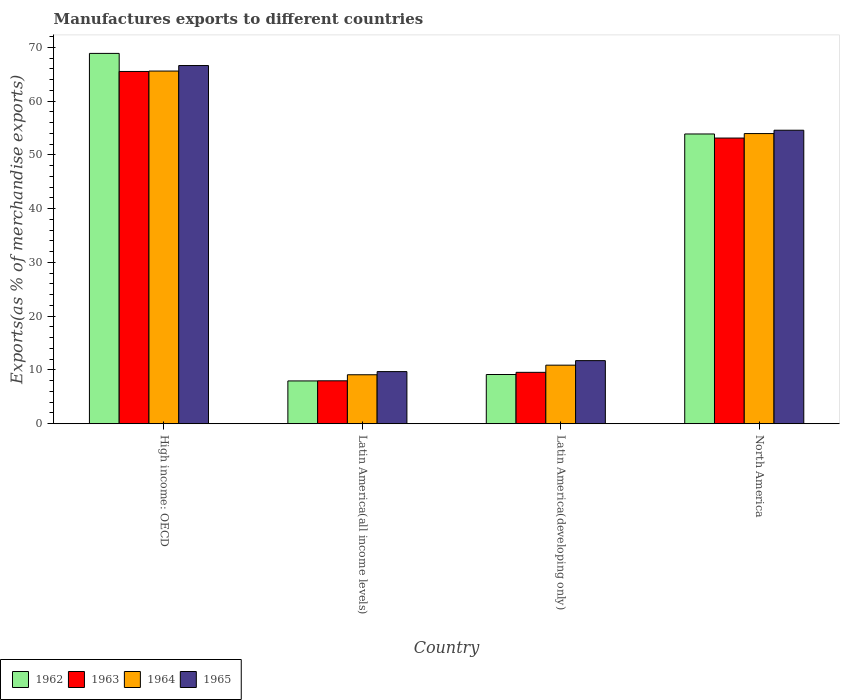Are the number of bars on each tick of the X-axis equal?
Ensure brevity in your answer.  Yes. In how many cases, is the number of bars for a given country not equal to the number of legend labels?
Provide a succinct answer. 0. What is the percentage of exports to different countries in 1962 in High income: OECD?
Give a very brief answer. 68.9. Across all countries, what is the maximum percentage of exports to different countries in 1963?
Keep it short and to the point. 65.54. Across all countries, what is the minimum percentage of exports to different countries in 1964?
Offer a terse response. 9.11. In which country was the percentage of exports to different countries in 1965 maximum?
Your response must be concise. High income: OECD. In which country was the percentage of exports to different countries in 1962 minimum?
Your answer should be very brief. Latin America(all income levels). What is the total percentage of exports to different countries in 1962 in the graph?
Your response must be concise. 139.93. What is the difference between the percentage of exports to different countries in 1965 in High income: OECD and that in Latin America(all income levels)?
Your answer should be compact. 56.94. What is the difference between the percentage of exports to different countries in 1962 in Latin America(all income levels) and the percentage of exports to different countries in 1965 in Latin America(developing only)?
Ensure brevity in your answer.  -3.78. What is the average percentage of exports to different countries in 1963 per country?
Offer a terse response. 34.06. What is the difference between the percentage of exports to different countries of/in 1963 and percentage of exports to different countries of/in 1964 in Latin America(developing only)?
Your answer should be very brief. -1.33. What is the ratio of the percentage of exports to different countries in 1964 in Latin America(all income levels) to that in Latin America(developing only)?
Your answer should be compact. 0.84. Is the percentage of exports to different countries in 1962 in Latin America(all income levels) less than that in Latin America(developing only)?
Give a very brief answer. Yes. What is the difference between the highest and the second highest percentage of exports to different countries in 1962?
Your response must be concise. -59.74. What is the difference between the highest and the lowest percentage of exports to different countries in 1964?
Offer a very short reply. 56.5. In how many countries, is the percentage of exports to different countries in 1962 greater than the average percentage of exports to different countries in 1962 taken over all countries?
Offer a terse response. 2. Is the sum of the percentage of exports to different countries in 1964 in High income: OECD and Latin America(all income levels) greater than the maximum percentage of exports to different countries in 1963 across all countries?
Provide a short and direct response. Yes. What does the 3rd bar from the left in High income: OECD represents?
Keep it short and to the point. 1964. What is the difference between two consecutive major ticks on the Y-axis?
Ensure brevity in your answer.  10. Are the values on the major ticks of Y-axis written in scientific E-notation?
Provide a succinct answer. No. How many legend labels are there?
Make the answer very short. 4. How are the legend labels stacked?
Keep it short and to the point. Horizontal. What is the title of the graph?
Make the answer very short. Manufactures exports to different countries. Does "1968" appear as one of the legend labels in the graph?
Keep it short and to the point. No. What is the label or title of the X-axis?
Your response must be concise. Country. What is the label or title of the Y-axis?
Your answer should be very brief. Exports(as % of merchandise exports). What is the Exports(as % of merchandise exports) in 1962 in High income: OECD?
Provide a succinct answer. 68.9. What is the Exports(as % of merchandise exports) of 1963 in High income: OECD?
Give a very brief answer. 65.54. What is the Exports(as % of merchandise exports) of 1964 in High income: OECD?
Provide a short and direct response. 65.61. What is the Exports(as % of merchandise exports) of 1965 in High income: OECD?
Ensure brevity in your answer.  66.64. What is the Exports(as % of merchandise exports) in 1962 in Latin America(all income levels)?
Keep it short and to the point. 7.96. What is the Exports(as % of merchandise exports) of 1963 in Latin America(all income levels)?
Your answer should be very brief. 7.99. What is the Exports(as % of merchandise exports) of 1964 in Latin America(all income levels)?
Your answer should be very brief. 9.11. What is the Exports(as % of merchandise exports) in 1965 in Latin America(all income levels)?
Provide a succinct answer. 9.7. What is the Exports(as % of merchandise exports) in 1962 in Latin America(developing only)?
Your answer should be very brief. 9.16. What is the Exports(as % of merchandise exports) in 1963 in Latin America(developing only)?
Your answer should be compact. 9.56. What is the Exports(as % of merchandise exports) in 1964 in Latin America(developing only)?
Offer a very short reply. 10.9. What is the Exports(as % of merchandise exports) in 1965 in Latin America(developing only)?
Provide a short and direct response. 11.74. What is the Exports(as % of merchandise exports) in 1962 in North America?
Your answer should be compact. 53.91. What is the Exports(as % of merchandise exports) in 1963 in North America?
Your answer should be compact. 53.15. What is the Exports(as % of merchandise exports) of 1964 in North America?
Offer a terse response. 53.98. What is the Exports(as % of merchandise exports) of 1965 in North America?
Your answer should be compact. 54.61. Across all countries, what is the maximum Exports(as % of merchandise exports) of 1962?
Ensure brevity in your answer.  68.9. Across all countries, what is the maximum Exports(as % of merchandise exports) in 1963?
Offer a very short reply. 65.54. Across all countries, what is the maximum Exports(as % of merchandise exports) in 1964?
Your answer should be compact. 65.61. Across all countries, what is the maximum Exports(as % of merchandise exports) in 1965?
Ensure brevity in your answer.  66.64. Across all countries, what is the minimum Exports(as % of merchandise exports) of 1962?
Offer a terse response. 7.96. Across all countries, what is the minimum Exports(as % of merchandise exports) in 1963?
Offer a very short reply. 7.99. Across all countries, what is the minimum Exports(as % of merchandise exports) of 1964?
Ensure brevity in your answer.  9.11. Across all countries, what is the minimum Exports(as % of merchandise exports) of 1965?
Keep it short and to the point. 9.7. What is the total Exports(as % of merchandise exports) of 1962 in the graph?
Make the answer very short. 139.93. What is the total Exports(as % of merchandise exports) of 1963 in the graph?
Ensure brevity in your answer.  136.24. What is the total Exports(as % of merchandise exports) in 1964 in the graph?
Your answer should be compact. 139.6. What is the total Exports(as % of merchandise exports) of 1965 in the graph?
Make the answer very short. 142.68. What is the difference between the Exports(as % of merchandise exports) in 1962 in High income: OECD and that in Latin America(all income levels)?
Provide a short and direct response. 60.93. What is the difference between the Exports(as % of merchandise exports) in 1963 in High income: OECD and that in Latin America(all income levels)?
Keep it short and to the point. 57.55. What is the difference between the Exports(as % of merchandise exports) in 1964 in High income: OECD and that in Latin America(all income levels)?
Make the answer very short. 56.5. What is the difference between the Exports(as % of merchandise exports) of 1965 in High income: OECD and that in Latin America(all income levels)?
Give a very brief answer. 56.94. What is the difference between the Exports(as % of merchandise exports) of 1962 in High income: OECD and that in Latin America(developing only)?
Provide a succinct answer. 59.74. What is the difference between the Exports(as % of merchandise exports) of 1963 in High income: OECD and that in Latin America(developing only)?
Offer a terse response. 55.98. What is the difference between the Exports(as % of merchandise exports) in 1964 in High income: OECD and that in Latin America(developing only)?
Provide a succinct answer. 54.72. What is the difference between the Exports(as % of merchandise exports) in 1965 in High income: OECD and that in Latin America(developing only)?
Make the answer very short. 54.9. What is the difference between the Exports(as % of merchandise exports) in 1962 in High income: OECD and that in North America?
Offer a terse response. 14.99. What is the difference between the Exports(as % of merchandise exports) of 1963 in High income: OECD and that in North America?
Ensure brevity in your answer.  12.39. What is the difference between the Exports(as % of merchandise exports) of 1964 in High income: OECD and that in North America?
Ensure brevity in your answer.  11.63. What is the difference between the Exports(as % of merchandise exports) of 1965 in High income: OECD and that in North America?
Ensure brevity in your answer.  12.03. What is the difference between the Exports(as % of merchandise exports) in 1962 in Latin America(all income levels) and that in Latin America(developing only)?
Ensure brevity in your answer.  -1.2. What is the difference between the Exports(as % of merchandise exports) in 1963 in Latin America(all income levels) and that in Latin America(developing only)?
Your answer should be compact. -1.57. What is the difference between the Exports(as % of merchandise exports) of 1964 in Latin America(all income levels) and that in Latin America(developing only)?
Make the answer very short. -1.78. What is the difference between the Exports(as % of merchandise exports) of 1965 in Latin America(all income levels) and that in Latin America(developing only)?
Ensure brevity in your answer.  -2.04. What is the difference between the Exports(as % of merchandise exports) in 1962 in Latin America(all income levels) and that in North America?
Your answer should be compact. -45.94. What is the difference between the Exports(as % of merchandise exports) in 1963 in Latin America(all income levels) and that in North America?
Your response must be concise. -45.16. What is the difference between the Exports(as % of merchandise exports) of 1964 in Latin America(all income levels) and that in North America?
Make the answer very short. -44.87. What is the difference between the Exports(as % of merchandise exports) of 1965 in Latin America(all income levels) and that in North America?
Provide a succinct answer. -44.91. What is the difference between the Exports(as % of merchandise exports) in 1962 in Latin America(developing only) and that in North America?
Your response must be concise. -44.75. What is the difference between the Exports(as % of merchandise exports) in 1963 in Latin America(developing only) and that in North America?
Keep it short and to the point. -43.59. What is the difference between the Exports(as % of merchandise exports) in 1964 in Latin America(developing only) and that in North America?
Provide a short and direct response. -43.09. What is the difference between the Exports(as % of merchandise exports) in 1965 in Latin America(developing only) and that in North America?
Your response must be concise. -42.87. What is the difference between the Exports(as % of merchandise exports) of 1962 in High income: OECD and the Exports(as % of merchandise exports) of 1963 in Latin America(all income levels)?
Offer a terse response. 60.91. What is the difference between the Exports(as % of merchandise exports) of 1962 in High income: OECD and the Exports(as % of merchandise exports) of 1964 in Latin America(all income levels)?
Make the answer very short. 59.79. What is the difference between the Exports(as % of merchandise exports) of 1962 in High income: OECD and the Exports(as % of merchandise exports) of 1965 in Latin America(all income levels)?
Provide a succinct answer. 59.2. What is the difference between the Exports(as % of merchandise exports) in 1963 in High income: OECD and the Exports(as % of merchandise exports) in 1964 in Latin America(all income levels)?
Keep it short and to the point. 56.43. What is the difference between the Exports(as % of merchandise exports) in 1963 in High income: OECD and the Exports(as % of merchandise exports) in 1965 in Latin America(all income levels)?
Provide a succinct answer. 55.84. What is the difference between the Exports(as % of merchandise exports) of 1964 in High income: OECD and the Exports(as % of merchandise exports) of 1965 in Latin America(all income levels)?
Your answer should be compact. 55.91. What is the difference between the Exports(as % of merchandise exports) in 1962 in High income: OECD and the Exports(as % of merchandise exports) in 1963 in Latin America(developing only)?
Provide a short and direct response. 59.34. What is the difference between the Exports(as % of merchandise exports) in 1962 in High income: OECD and the Exports(as % of merchandise exports) in 1964 in Latin America(developing only)?
Provide a succinct answer. 58. What is the difference between the Exports(as % of merchandise exports) of 1962 in High income: OECD and the Exports(as % of merchandise exports) of 1965 in Latin America(developing only)?
Give a very brief answer. 57.16. What is the difference between the Exports(as % of merchandise exports) in 1963 in High income: OECD and the Exports(as % of merchandise exports) in 1964 in Latin America(developing only)?
Ensure brevity in your answer.  54.64. What is the difference between the Exports(as % of merchandise exports) of 1963 in High income: OECD and the Exports(as % of merchandise exports) of 1965 in Latin America(developing only)?
Offer a terse response. 53.8. What is the difference between the Exports(as % of merchandise exports) in 1964 in High income: OECD and the Exports(as % of merchandise exports) in 1965 in Latin America(developing only)?
Ensure brevity in your answer.  53.87. What is the difference between the Exports(as % of merchandise exports) of 1962 in High income: OECD and the Exports(as % of merchandise exports) of 1963 in North America?
Ensure brevity in your answer.  15.75. What is the difference between the Exports(as % of merchandise exports) of 1962 in High income: OECD and the Exports(as % of merchandise exports) of 1964 in North America?
Ensure brevity in your answer.  14.92. What is the difference between the Exports(as % of merchandise exports) of 1962 in High income: OECD and the Exports(as % of merchandise exports) of 1965 in North America?
Keep it short and to the point. 14.29. What is the difference between the Exports(as % of merchandise exports) in 1963 in High income: OECD and the Exports(as % of merchandise exports) in 1964 in North America?
Ensure brevity in your answer.  11.56. What is the difference between the Exports(as % of merchandise exports) of 1963 in High income: OECD and the Exports(as % of merchandise exports) of 1965 in North America?
Provide a short and direct response. 10.93. What is the difference between the Exports(as % of merchandise exports) of 1964 in High income: OECD and the Exports(as % of merchandise exports) of 1965 in North America?
Provide a short and direct response. 11.01. What is the difference between the Exports(as % of merchandise exports) of 1962 in Latin America(all income levels) and the Exports(as % of merchandise exports) of 1963 in Latin America(developing only)?
Provide a short and direct response. -1.6. What is the difference between the Exports(as % of merchandise exports) in 1962 in Latin America(all income levels) and the Exports(as % of merchandise exports) in 1964 in Latin America(developing only)?
Provide a short and direct response. -2.93. What is the difference between the Exports(as % of merchandise exports) of 1962 in Latin America(all income levels) and the Exports(as % of merchandise exports) of 1965 in Latin America(developing only)?
Make the answer very short. -3.78. What is the difference between the Exports(as % of merchandise exports) in 1963 in Latin America(all income levels) and the Exports(as % of merchandise exports) in 1964 in Latin America(developing only)?
Provide a short and direct response. -2.91. What is the difference between the Exports(as % of merchandise exports) of 1963 in Latin America(all income levels) and the Exports(as % of merchandise exports) of 1965 in Latin America(developing only)?
Keep it short and to the point. -3.75. What is the difference between the Exports(as % of merchandise exports) of 1964 in Latin America(all income levels) and the Exports(as % of merchandise exports) of 1965 in Latin America(developing only)?
Ensure brevity in your answer.  -2.63. What is the difference between the Exports(as % of merchandise exports) of 1962 in Latin America(all income levels) and the Exports(as % of merchandise exports) of 1963 in North America?
Offer a very short reply. -45.18. What is the difference between the Exports(as % of merchandise exports) of 1962 in Latin America(all income levels) and the Exports(as % of merchandise exports) of 1964 in North America?
Keep it short and to the point. -46.02. What is the difference between the Exports(as % of merchandise exports) in 1962 in Latin America(all income levels) and the Exports(as % of merchandise exports) in 1965 in North America?
Your response must be concise. -46.64. What is the difference between the Exports(as % of merchandise exports) of 1963 in Latin America(all income levels) and the Exports(as % of merchandise exports) of 1964 in North America?
Make the answer very short. -45.99. What is the difference between the Exports(as % of merchandise exports) in 1963 in Latin America(all income levels) and the Exports(as % of merchandise exports) in 1965 in North America?
Offer a terse response. -46.62. What is the difference between the Exports(as % of merchandise exports) of 1964 in Latin America(all income levels) and the Exports(as % of merchandise exports) of 1965 in North America?
Offer a very short reply. -45.49. What is the difference between the Exports(as % of merchandise exports) of 1962 in Latin America(developing only) and the Exports(as % of merchandise exports) of 1963 in North America?
Provide a short and direct response. -43.99. What is the difference between the Exports(as % of merchandise exports) in 1962 in Latin America(developing only) and the Exports(as % of merchandise exports) in 1964 in North America?
Give a very brief answer. -44.82. What is the difference between the Exports(as % of merchandise exports) of 1962 in Latin America(developing only) and the Exports(as % of merchandise exports) of 1965 in North America?
Ensure brevity in your answer.  -45.45. What is the difference between the Exports(as % of merchandise exports) of 1963 in Latin America(developing only) and the Exports(as % of merchandise exports) of 1964 in North America?
Your answer should be compact. -44.42. What is the difference between the Exports(as % of merchandise exports) of 1963 in Latin America(developing only) and the Exports(as % of merchandise exports) of 1965 in North America?
Provide a succinct answer. -45.04. What is the difference between the Exports(as % of merchandise exports) in 1964 in Latin America(developing only) and the Exports(as % of merchandise exports) in 1965 in North America?
Provide a succinct answer. -43.71. What is the average Exports(as % of merchandise exports) of 1962 per country?
Offer a terse response. 34.98. What is the average Exports(as % of merchandise exports) of 1963 per country?
Your response must be concise. 34.06. What is the average Exports(as % of merchandise exports) in 1964 per country?
Your response must be concise. 34.9. What is the average Exports(as % of merchandise exports) in 1965 per country?
Provide a succinct answer. 35.67. What is the difference between the Exports(as % of merchandise exports) of 1962 and Exports(as % of merchandise exports) of 1963 in High income: OECD?
Give a very brief answer. 3.36. What is the difference between the Exports(as % of merchandise exports) of 1962 and Exports(as % of merchandise exports) of 1964 in High income: OECD?
Provide a succinct answer. 3.28. What is the difference between the Exports(as % of merchandise exports) of 1962 and Exports(as % of merchandise exports) of 1965 in High income: OECD?
Provide a succinct answer. 2.26. What is the difference between the Exports(as % of merchandise exports) in 1963 and Exports(as % of merchandise exports) in 1964 in High income: OECD?
Provide a succinct answer. -0.08. What is the difference between the Exports(as % of merchandise exports) of 1963 and Exports(as % of merchandise exports) of 1965 in High income: OECD?
Your answer should be very brief. -1.1. What is the difference between the Exports(as % of merchandise exports) in 1964 and Exports(as % of merchandise exports) in 1965 in High income: OECD?
Your answer should be very brief. -1.02. What is the difference between the Exports(as % of merchandise exports) of 1962 and Exports(as % of merchandise exports) of 1963 in Latin America(all income levels)?
Keep it short and to the point. -0.02. What is the difference between the Exports(as % of merchandise exports) in 1962 and Exports(as % of merchandise exports) in 1964 in Latin America(all income levels)?
Your answer should be compact. -1.15. What is the difference between the Exports(as % of merchandise exports) in 1962 and Exports(as % of merchandise exports) in 1965 in Latin America(all income levels)?
Provide a short and direct response. -1.74. What is the difference between the Exports(as % of merchandise exports) of 1963 and Exports(as % of merchandise exports) of 1964 in Latin America(all income levels)?
Give a very brief answer. -1.12. What is the difference between the Exports(as % of merchandise exports) in 1963 and Exports(as % of merchandise exports) in 1965 in Latin America(all income levels)?
Your response must be concise. -1.71. What is the difference between the Exports(as % of merchandise exports) in 1964 and Exports(as % of merchandise exports) in 1965 in Latin America(all income levels)?
Your response must be concise. -0.59. What is the difference between the Exports(as % of merchandise exports) in 1962 and Exports(as % of merchandise exports) in 1963 in Latin America(developing only)?
Keep it short and to the point. -0.4. What is the difference between the Exports(as % of merchandise exports) of 1962 and Exports(as % of merchandise exports) of 1964 in Latin America(developing only)?
Keep it short and to the point. -1.74. What is the difference between the Exports(as % of merchandise exports) of 1962 and Exports(as % of merchandise exports) of 1965 in Latin America(developing only)?
Offer a very short reply. -2.58. What is the difference between the Exports(as % of merchandise exports) in 1963 and Exports(as % of merchandise exports) in 1964 in Latin America(developing only)?
Your answer should be compact. -1.33. What is the difference between the Exports(as % of merchandise exports) of 1963 and Exports(as % of merchandise exports) of 1965 in Latin America(developing only)?
Provide a short and direct response. -2.18. What is the difference between the Exports(as % of merchandise exports) in 1964 and Exports(as % of merchandise exports) in 1965 in Latin America(developing only)?
Give a very brief answer. -0.84. What is the difference between the Exports(as % of merchandise exports) of 1962 and Exports(as % of merchandise exports) of 1963 in North America?
Give a very brief answer. 0.76. What is the difference between the Exports(as % of merchandise exports) in 1962 and Exports(as % of merchandise exports) in 1964 in North America?
Your answer should be very brief. -0.08. What is the difference between the Exports(as % of merchandise exports) of 1962 and Exports(as % of merchandise exports) of 1965 in North America?
Give a very brief answer. -0.7. What is the difference between the Exports(as % of merchandise exports) of 1963 and Exports(as % of merchandise exports) of 1964 in North America?
Provide a short and direct response. -0.84. What is the difference between the Exports(as % of merchandise exports) in 1963 and Exports(as % of merchandise exports) in 1965 in North America?
Your answer should be very brief. -1.46. What is the difference between the Exports(as % of merchandise exports) in 1964 and Exports(as % of merchandise exports) in 1965 in North America?
Give a very brief answer. -0.62. What is the ratio of the Exports(as % of merchandise exports) of 1962 in High income: OECD to that in Latin America(all income levels)?
Your answer should be compact. 8.65. What is the ratio of the Exports(as % of merchandise exports) in 1963 in High income: OECD to that in Latin America(all income levels)?
Offer a very short reply. 8.2. What is the ratio of the Exports(as % of merchandise exports) of 1964 in High income: OECD to that in Latin America(all income levels)?
Your response must be concise. 7.2. What is the ratio of the Exports(as % of merchandise exports) of 1965 in High income: OECD to that in Latin America(all income levels)?
Make the answer very short. 6.87. What is the ratio of the Exports(as % of merchandise exports) in 1962 in High income: OECD to that in Latin America(developing only)?
Make the answer very short. 7.52. What is the ratio of the Exports(as % of merchandise exports) in 1963 in High income: OECD to that in Latin America(developing only)?
Your answer should be very brief. 6.85. What is the ratio of the Exports(as % of merchandise exports) in 1964 in High income: OECD to that in Latin America(developing only)?
Offer a terse response. 6.02. What is the ratio of the Exports(as % of merchandise exports) in 1965 in High income: OECD to that in Latin America(developing only)?
Your answer should be compact. 5.68. What is the ratio of the Exports(as % of merchandise exports) of 1962 in High income: OECD to that in North America?
Offer a terse response. 1.28. What is the ratio of the Exports(as % of merchandise exports) of 1963 in High income: OECD to that in North America?
Your response must be concise. 1.23. What is the ratio of the Exports(as % of merchandise exports) of 1964 in High income: OECD to that in North America?
Your answer should be compact. 1.22. What is the ratio of the Exports(as % of merchandise exports) of 1965 in High income: OECD to that in North America?
Your answer should be very brief. 1.22. What is the ratio of the Exports(as % of merchandise exports) in 1962 in Latin America(all income levels) to that in Latin America(developing only)?
Ensure brevity in your answer.  0.87. What is the ratio of the Exports(as % of merchandise exports) of 1963 in Latin America(all income levels) to that in Latin America(developing only)?
Keep it short and to the point. 0.84. What is the ratio of the Exports(as % of merchandise exports) of 1964 in Latin America(all income levels) to that in Latin America(developing only)?
Your answer should be compact. 0.84. What is the ratio of the Exports(as % of merchandise exports) of 1965 in Latin America(all income levels) to that in Latin America(developing only)?
Offer a terse response. 0.83. What is the ratio of the Exports(as % of merchandise exports) of 1962 in Latin America(all income levels) to that in North America?
Keep it short and to the point. 0.15. What is the ratio of the Exports(as % of merchandise exports) in 1963 in Latin America(all income levels) to that in North America?
Provide a succinct answer. 0.15. What is the ratio of the Exports(as % of merchandise exports) in 1964 in Latin America(all income levels) to that in North America?
Your answer should be very brief. 0.17. What is the ratio of the Exports(as % of merchandise exports) in 1965 in Latin America(all income levels) to that in North America?
Your answer should be compact. 0.18. What is the ratio of the Exports(as % of merchandise exports) of 1962 in Latin America(developing only) to that in North America?
Offer a very short reply. 0.17. What is the ratio of the Exports(as % of merchandise exports) of 1963 in Latin America(developing only) to that in North America?
Your answer should be compact. 0.18. What is the ratio of the Exports(as % of merchandise exports) in 1964 in Latin America(developing only) to that in North America?
Ensure brevity in your answer.  0.2. What is the ratio of the Exports(as % of merchandise exports) of 1965 in Latin America(developing only) to that in North America?
Provide a succinct answer. 0.21. What is the difference between the highest and the second highest Exports(as % of merchandise exports) in 1962?
Offer a terse response. 14.99. What is the difference between the highest and the second highest Exports(as % of merchandise exports) in 1963?
Make the answer very short. 12.39. What is the difference between the highest and the second highest Exports(as % of merchandise exports) of 1964?
Ensure brevity in your answer.  11.63. What is the difference between the highest and the second highest Exports(as % of merchandise exports) of 1965?
Keep it short and to the point. 12.03. What is the difference between the highest and the lowest Exports(as % of merchandise exports) of 1962?
Make the answer very short. 60.93. What is the difference between the highest and the lowest Exports(as % of merchandise exports) in 1963?
Keep it short and to the point. 57.55. What is the difference between the highest and the lowest Exports(as % of merchandise exports) of 1964?
Ensure brevity in your answer.  56.5. What is the difference between the highest and the lowest Exports(as % of merchandise exports) of 1965?
Offer a very short reply. 56.94. 